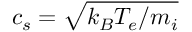Convert formula to latex. <formula><loc_0><loc_0><loc_500><loc_500>c _ { s } = \sqrt { k _ { B } T _ { e } / m _ { i } }</formula> 